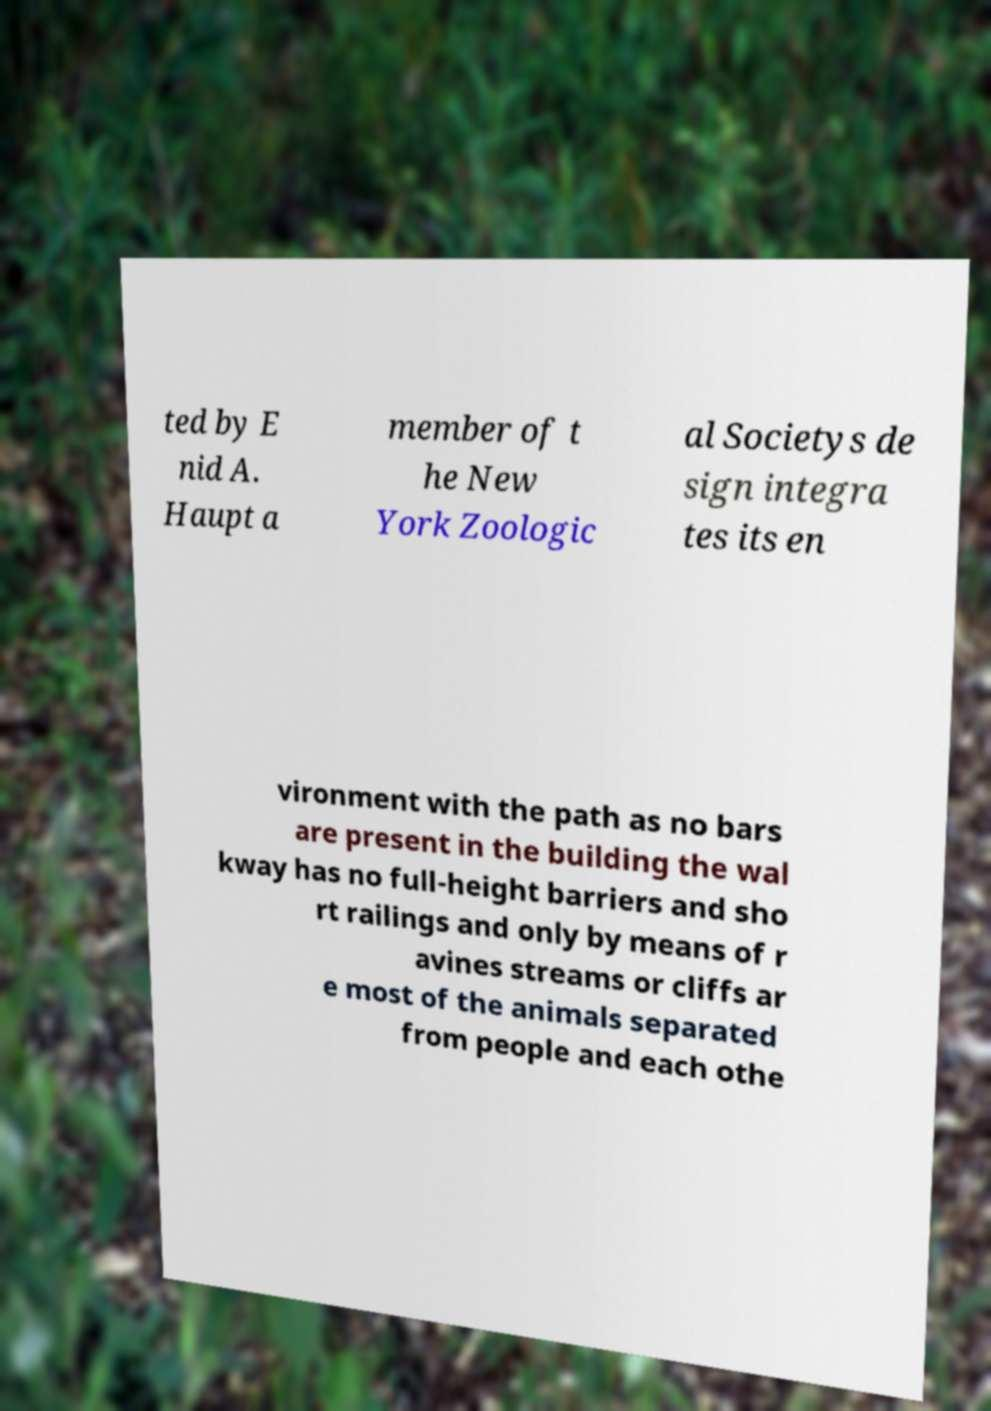Could you assist in decoding the text presented in this image and type it out clearly? ted by E nid A. Haupt a member of t he New York Zoologic al Societys de sign integra tes its en vironment with the path as no bars are present in the building the wal kway has no full-height barriers and sho rt railings and only by means of r avines streams or cliffs ar e most of the animals separated from people and each othe 